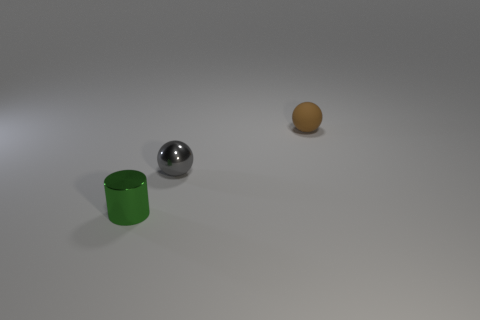Are there any other things that are the same material as the brown object?
Ensure brevity in your answer.  No. Is there any other thing that is the same shape as the green metal thing?
Your answer should be very brief. No. How many metal cylinders have the same color as the rubber object?
Give a very brief answer. 0. How many small things are either gray rubber cubes or gray things?
Make the answer very short. 1. Is there a cylinder made of the same material as the gray ball?
Your response must be concise. Yes. What is the small ball on the left side of the tiny rubber sphere made of?
Your answer should be very brief. Metal. There is a sphere in front of the small brown rubber object; does it have the same color as the small object that is in front of the small gray sphere?
Your answer should be compact. No. What color is the matte thing that is the same size as the shiny sphere?
Give a very brief answer. Brown. How many other objects are the same shape as the small gray metal thing?
Your answer should be very brief. 1. There is a ball on the left side of the tiny brown matte sphere; how big is it?
Provide a short and direct response. Small. 